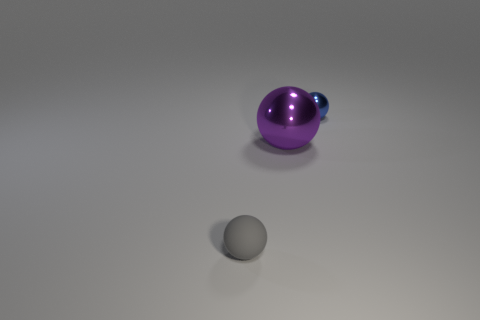Add 1 blue metal balls. How many objects exist? 4 Subtract all big metal objects. Subtract all tiny blue metallic things. How many objects are left? 1 Add 3 small blue spheres. How many small blue spheres are left? 4 Add 1 small gray objects. How many small gray objects exist? 2 Subtract 0 gray cylinders. How many objects are left? 3 